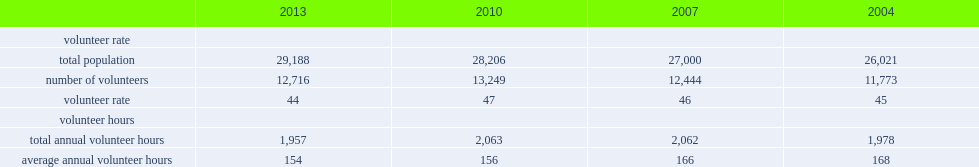How many canadians aged 15 years and older participated in some form of volunteer work in 2013? 12716.0. What was the percentage of canadians aged 15 years and older participated in some form of volunteer work in 2013? 44.0. Which year's total number of volunteers was lower,2013 or 2010? 2013.0. How many hours did volunteers devote to their volunteer activities in 2013? 1957.0. 